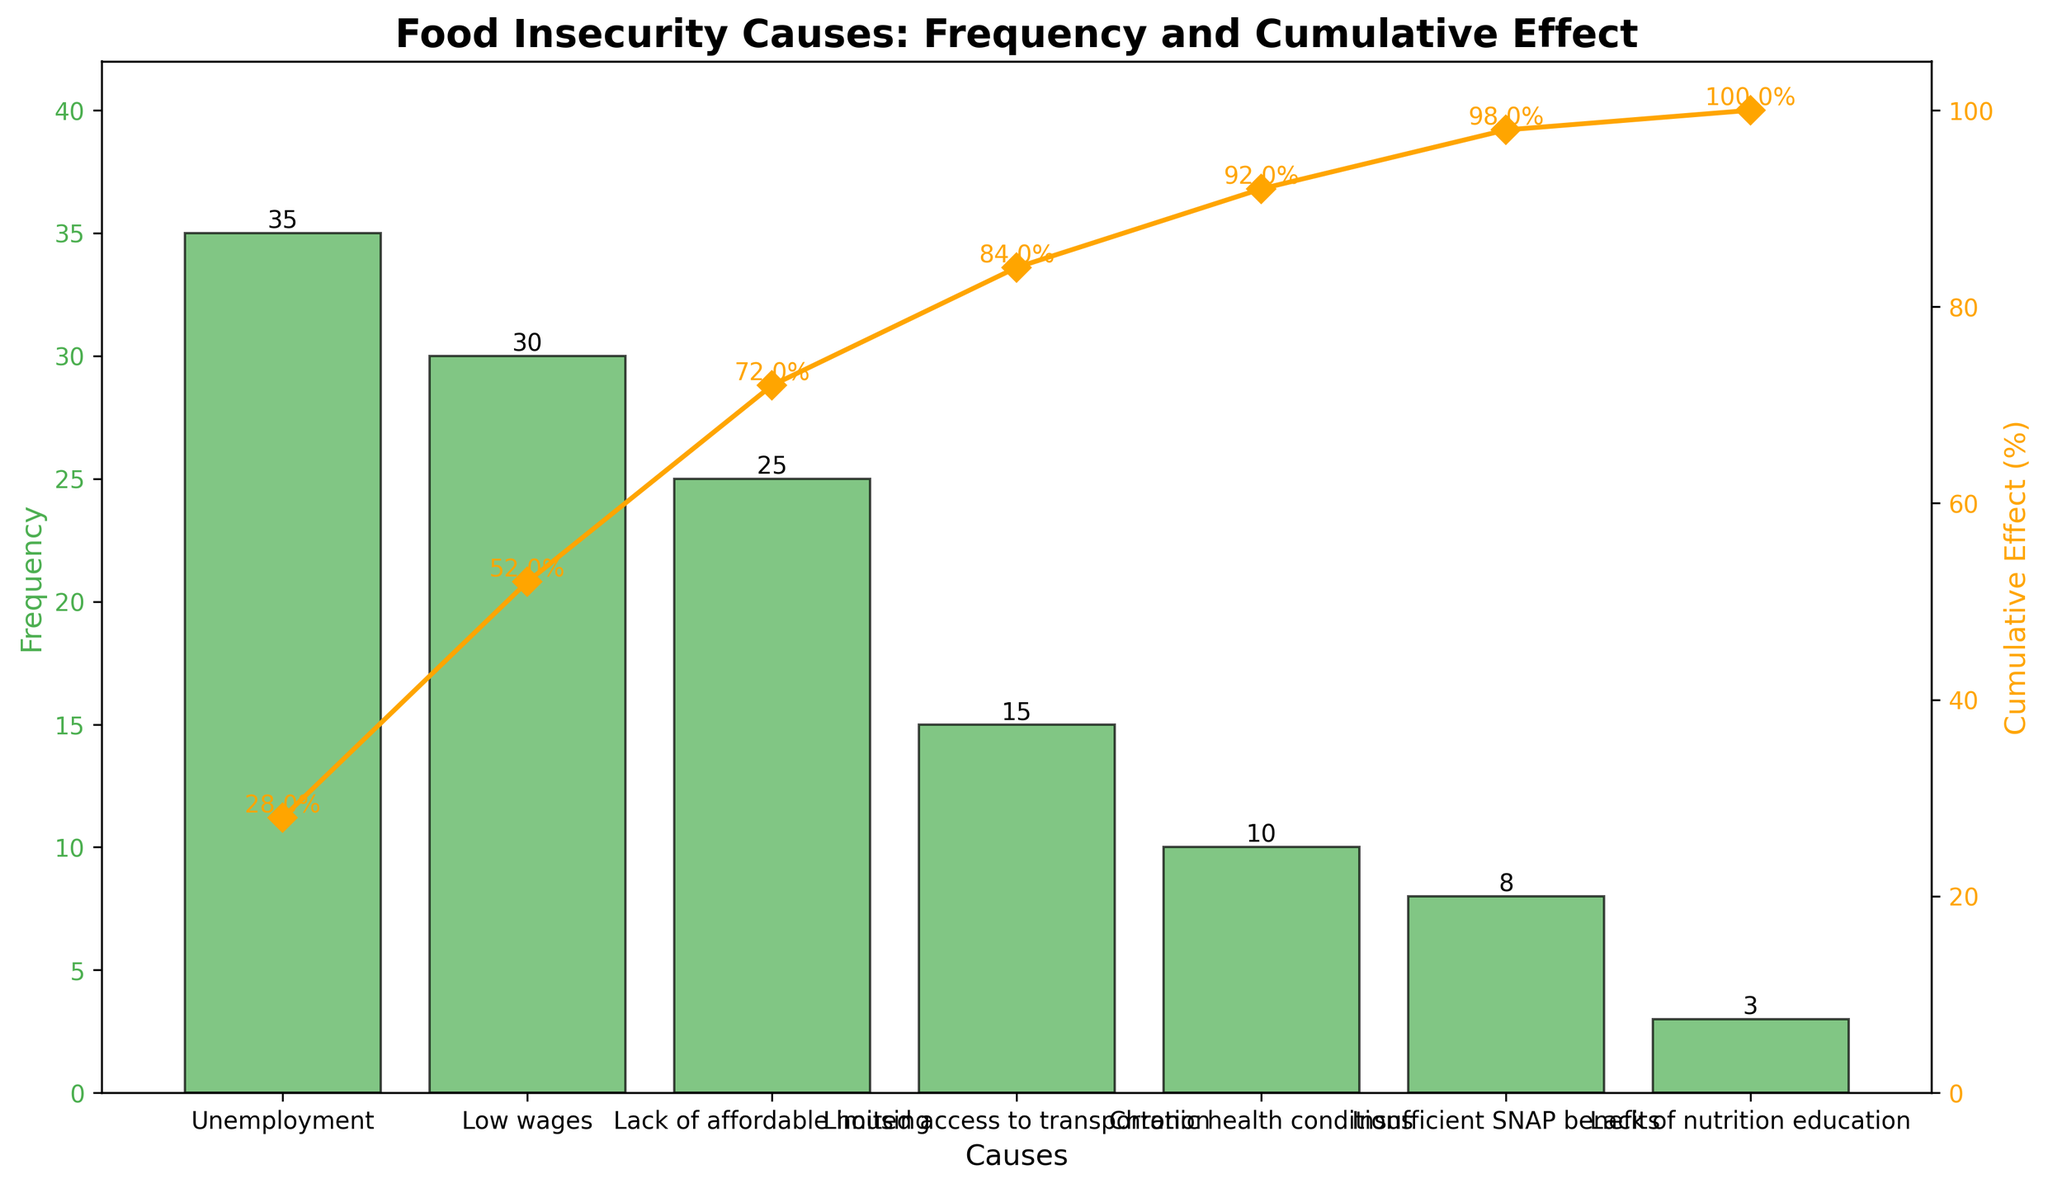What's the title of the chart? The title of the chart is displayed at the top and provides a description of what the chart represents: "Food Insecurity Causes: Frequency and Cumulative Effect"
Answer: Food Insecurity Causes: Frequency and Cumulative Effect How many causes of food insecurity are mentioned in the chart? By counting the bars representing each cause, we see there are seven different causes.
Answer: Seven Which cause of food insecurity has the highest frequency? The frequency is indicated by the height of the bars. The tallest bar belongs to "Unemployment" with a frequency of 35.
Answer: Unemployment What is the cumulative effect (%) of Low wages? The cumulative effect of Low wages is directly indicated by the line graph and the associated text marker. It is 52%.
Answer: 52% What is the combined frequency of Limited access to transportation and Chronic health conditions? The frequency of Limited access to transportation is 15 and Chronic health conditions is 10. Adding these frequencies gives 15 + 10 = 25.
Answer: 25 What percentage does Insufficient SNAP benefits contribute to the cumulative effect? The cumulative effect lines and text markers indicate the percentage. Insufficient SNAP benefits have a cumulative effect of 98%.
Answer: 98% How does the cumulative effect of Lack of affordable housing compare to Limited access to transportation? The cumulative effect of Lack of affordable housing is 72%, while Limited access to transportation is 84%. Comparing these values, 84% is greater than 72%.
Answer: 84% > 72% What’s the difference in frequency between the highest cause and the lowest cause of food insecurity? The highest cause is Unemployment with a frequency of 35, and the lowest is Lack of nutrition education with a frequency of 3. The difference is 35 - 3 = 32.
Answer: 32 What percentage of the cumulative effect is reached by the top three causes? The top three causes are Unemployment (28%), Low wages (52%), and Lack of affordable housing (72%). The cumulative effect is directly given for these causes, so by Lack of affordable housing, it reaches 72%.
Answer: 72% How much higher is the frequency of Low wages compared to Insufficient SNAP benefits? The frequency of Low wages is 30, and Insufficient SNAP benefits is 8. The difference in frequency is 30 - 8 = 22.
Answer: 22 